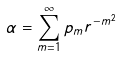Convert formula to latex. <formula><loc_0><loc_0><loc_500><loc_500>\alpha = \sum _ { m = 1 } ^ { \infty } p _ { m } r ^ { - m ^ { 2 } }</formula> 